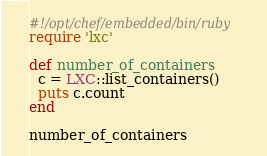Convert code to text. <code><loc_0><loc_0><loc_500><loc_500><_Ruby_>#!/opt/chef/embedded/bin/ruby
require 'lxc'

def number_of_containers
  c = LXC::list_containers()
  puts c.count
end

number_of_containers

</code> 